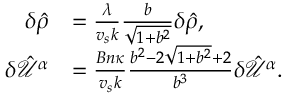Convert formula to latex. <formula><loc_0><loc_0><loc_500><loc_500>\begin{array} { r l } { \delta \hat { \rho } } & { = \frac { \lambda } { v _ { s } k } \frac { b } { \sqrt { 1 + b ^ { 2 } } } \delta \hat { \rho } , } \\ { \delta \hat { \mathcal { U } } ^ { \alpha } } & { = \frac { B n \kappa } { v _ { s } k } \frac { b ^ { 2 } - 2 \sqrt { 1 + b ^ { 2 } } + 2 } { b ^ { 3 } } \delta \hat { \mathcal { U } } ^ { \alpha } . } \end{array}</formula> 